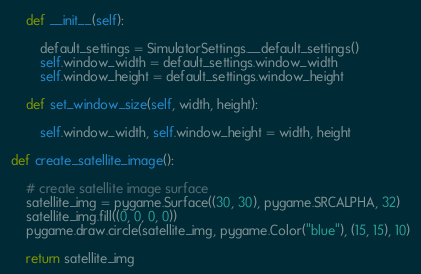Convert code to text. <code><loc_0><loc_0><loc_500><loc_500><_Python_>
    def __init__(self):

        default_settings = SimulatorSettings.__default_settings()
        self.window_width = default_settings.window_width
        self.window_height = default_settings.window_height

    def set_window_size(self, width, height):

        self.window_width, self.window_height = width, height

def create_satellite_image():

    # create satellite image surface
    satellite_img = pygame.Surface((30, 30), pygame.SRCALPHA, 32)
    satellite_img.fill((0, 0, 0, 0))
    pygame.draw.circle(satellite_img, pygame.Color("blue"), (15, 15), 10)

    return satellite_img</code> 